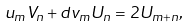<formula> <loc_0><loc_0><loc_500><loc_500>u _ { m } V _ { n } + d v _ { m } U _ { n } = 2 U _ { m + n } , \text { \quad }</formula> 